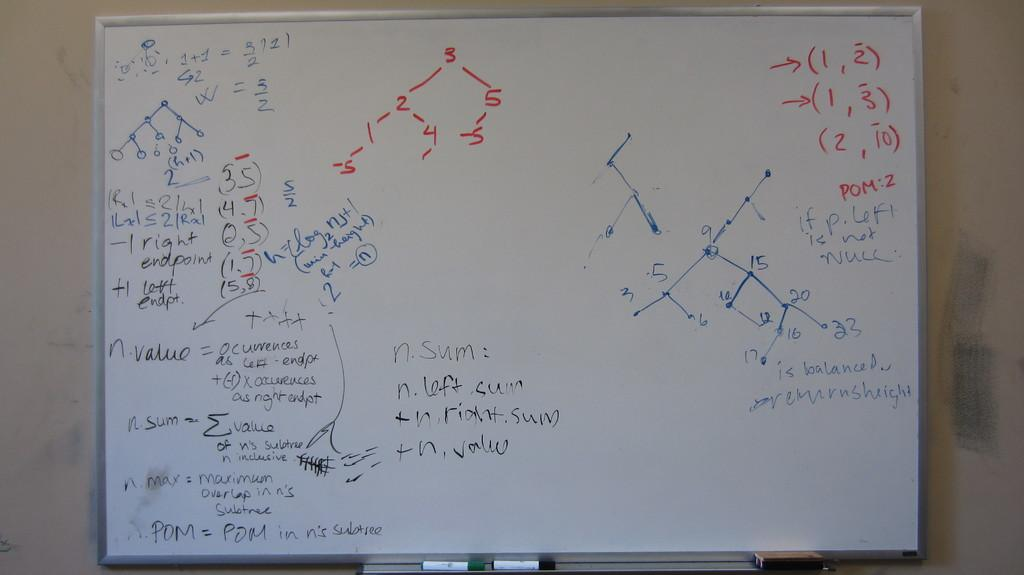Provide a one-sentence caption for the provided image. A A whiteboard showing multiple algebra equations with multiple points and steps. 